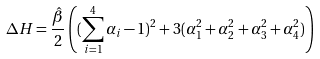Convert formula to latex. <formula><loc_0><loc_0><loc_500><loc_500>\Delta H = \frac { \hat { \beta } } { 2 } \left ( ( \sum _ { i = 1 } ^ { 4 } \alpha _ { i } - 1 ) ^ { 2 } + 3 ( \alpha _ { 1 } ^ { 2 } + \alpha _ { 2 } ^ { 2 } + \alpha _ { 3 } ^ { 2 } + \alpha _ { 4 } ^ { 2 } ) \right )</formula> 